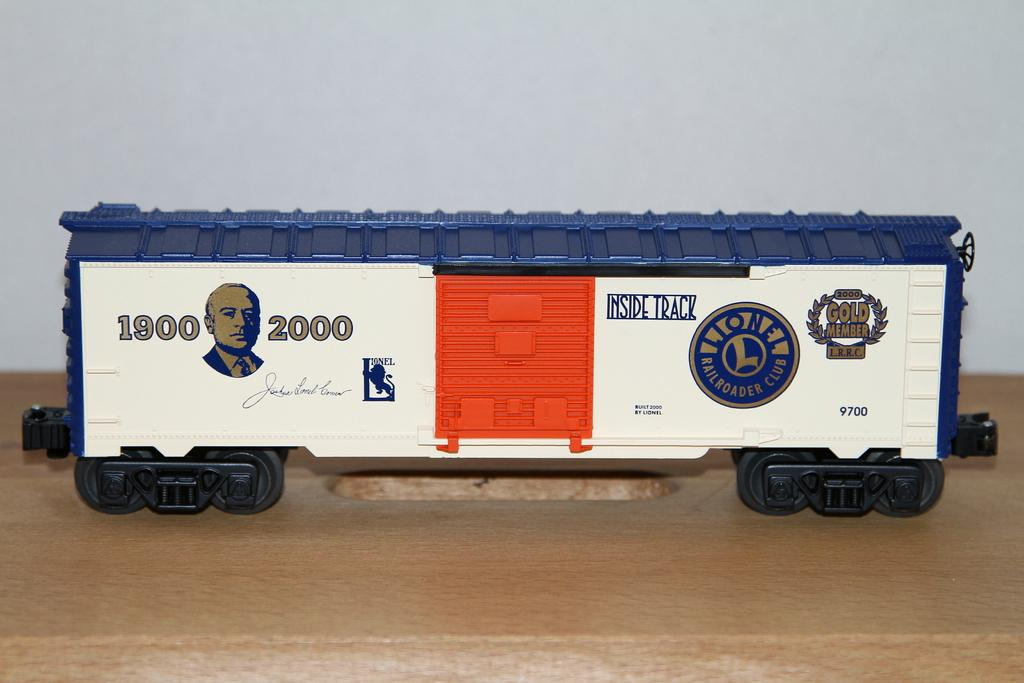What type of toy is depicted in the picture? There is a toy of a railway compartment in the picture. What can be observed on the surface of the toy? The toy has pictures painted on it. Are there any words present on the toy? Yes, there are words written on the toy. How does the bomb affect the toy in the image? There is no bomb present in the image, so it cannot affect the toy. What type of wish is granted by the toy in the image? There is no mention of wishes or any magical properties associated with the toy in the image. 